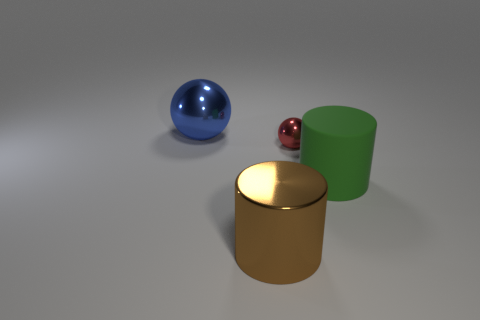Is there a color here that is most dominant, and if so, which object exemplifies it? The color green seems most dominant, as the green cylinder stands out due to its size and solid, uniform color. 